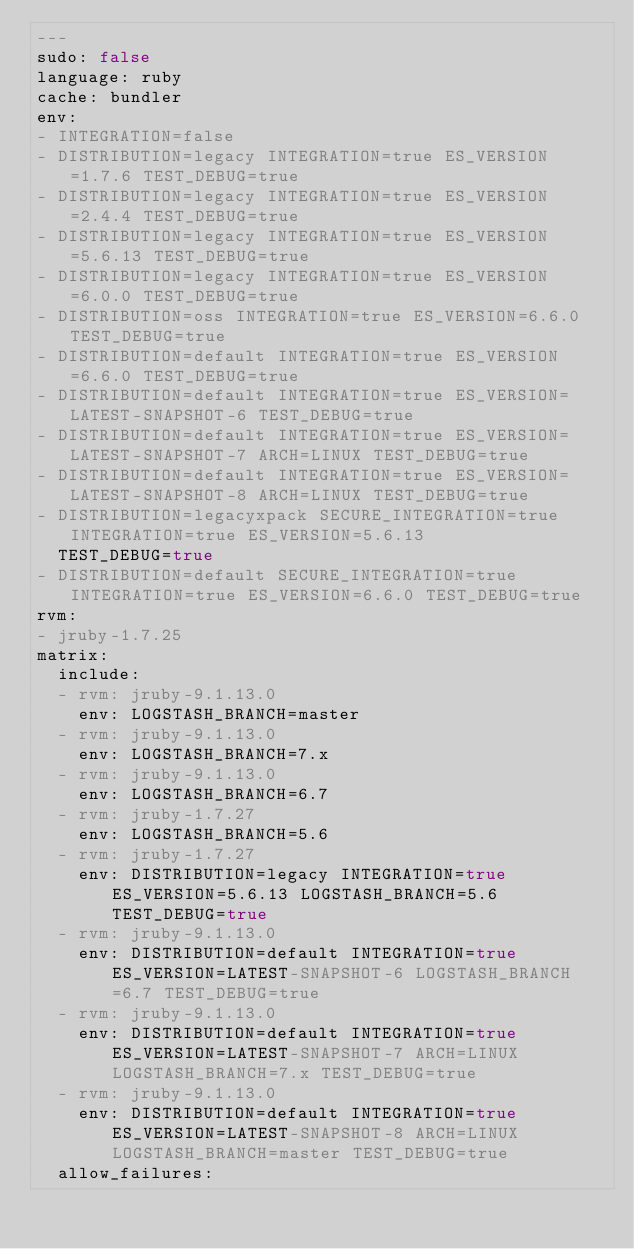Convert code to text. <code><loc_0><loc_0><loc_500><loc_500><_YAML_>---
sudo: false
language: ruby
cache: bundler
env:
- INTEGRATION=false
- DISTRIBUTION=legacy INTEGRATION=true ES_VERSION=1.7.6 TEST_DEBUG=true
- DISTRIBUTION=legacy INTEGRATION=true ES_VERSION=2.4.4 TEST_DEBUG=true
- DISTRIBUTION=legacy INTEGRATION=true ES_VERSION=5.6.13 TEST_DEBUG=true
- DISTRIBUTION=legacy INTEGRATION=true ES_VERSION=6.0.0 TEST_DEBUG=true
- DISTRIBUTION=oss INTEGRATION=true ES_VERSION=6.6.0 TEST_DEBUG=true
- DISTRIBUTION=default INTEGRATION=true ES_VERSION=6.6.0 TEST_DEBUG=true
- DISTRIBUTION=default INTEGRATION=true ES_VERSION=LATEST-SNAPSHOT-6 TEST_DEBUG=true
- DISTRIBUTION=default INTEGRATION=true ES_VERSION=LATEST-SNAPSHOT-7 ARCH=LINUX TEST_DEBUG=true
- DISTRIBUTION=default INTEGRATION=true ES_VERSION=LATEST-SNAPSHOT-8 ARCH=LINUX TEST_DEBUG=true
- DISTRIBUTION=legacyxpack SECURE_INTEGRATION=true INTEGRATION=true ES_VERSION=5.6.13
  TEST_DEBUG=true
- DISTRIBUTION=default SECURE_INTEGRATION=true INTEGRATION=true ES_VERSION=6.6.0 TEST_DEBUG=true
rvm:
- jruby-1.7.25
matrix:
  include:
  - rvm: jruby-9.1.13.0
    env: LOGSTASH_BRANCH=master
  - rvm: jruby-9.1.13.0
    env: LOGSTASH_BRANCH=7.x
  - rvm: jruby-9.1.13.0
    env: LOGSTASH_BRANCH=6.7
  - rvm: jruby-1.7.27
    env: LOGSTASH_BRANCH=5.6
  - rvm: jruby-1.7.27
    env: DISTRIBUTION=legacy INTEGRATION=true ES_VERSION=5.6.13 LOGSTASH_BRANCH=5.6 TEST_DEBUG=true
  - rvm: jruby-9.1.13.0
    env: DISTRIBUTION=default INTEGRATION=true ES_VERSION=LATEST-SNAPSHOT-6 LOGSTASH_BRANCH=6.7 TEST_DEBUG=true
  - rvm: jruby-9.1.13.0
    env: DISTRIBUTION=default INTEGRATION=true ES_VERSION=LATEST-SNAPSHOT-7 ARCH=LINUX LOGSTASH_BRANCH=7.x TEST_DEBUG=true
  - rvm: jruby-9.1.13.0
    env: DISTRIBUTION=default INTEGRATION=true ES_VERSION=LATEST-SNAPSHOT-8 ARCH=LINUX LOGSTASH_BRANCH=master TEST_DEBUG=true
  allow_failures:</code> 